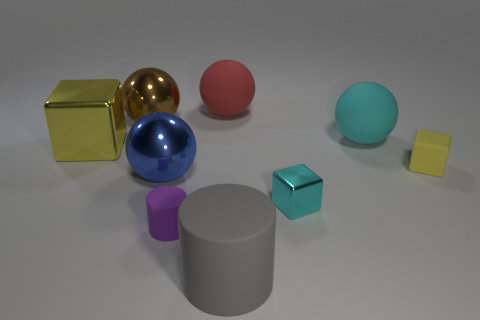Does the tiny rubber block have the same color as the metallic cube that is on the right side of the blue object?
Offer a very short reply. No. There is a block that is both behind the small cyan metal block and right of the gray cylinder; what color is it?
Your response must be concise. Yellow. There is a rubber ball that is in front of the red rubber object; what number of things are in front of it?
Make the answer very short. 6. Are there any red matte objects of the same shape as the cyan metallic object?
Offer a very short reply. No. Does the yellow object that is on the right side of the large gray cylinder have the same shape as the shiny thing that is right of the red rubber sphere?
Your answer should be compact. Yes. What number of things are either purple rubber things or small blue rubber spheres?
Provide a succinct answer. 1. What is the size of the purple matte thing that is the same shape as the big gray object?
Keep it short and to the point. Small. Are there more shiny objects that are behind the blue shiny sphere than large cyan rubber cylinders?
Your response must be concise. Yes. Does the large blue ball have the same material as the large red ball?
Keep it short and to the point. No. What number of things are either large metal things that are in front of the yellow shiny thing or big red objects behind the blue shiny sphere?
Keep it short and to the point. 2. 